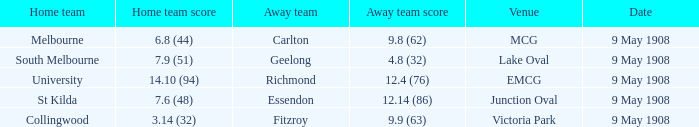Name the home team score for south melbourne home team 7.9 (51). 